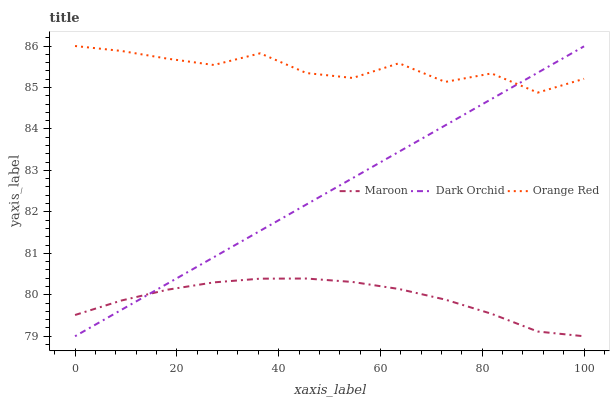Does Maroon have the minimum area under the curve?
Answer yes or no. Yes. Does Orange Red have the maximum area under the curve?
Answer yes or no. Yes. Does Orange Red have the minimum area under the curve?
Answer yes or no. No. Does Maroon have the maximum area under the curve?
Answer yes or no. No. Is Dark Orchid the smoothest?
Answer yes or no. Yes. Is Orange Red the roughest?
Answer yes or no. Yes. Is Maroon the smoothest?
Answer yes or no. No. Is Maroon the roughest?
Answer yes or no. No. Does Dark Orchid have the lowest value?
Answer yes or no. Yes. Does Orange Red have the lowest value?
Answer yes or no. No. Does Orange Red have the highest value?
Answer yes or no. Yes. Does Maroon have the highest value?
Answer yes or no. No. Is Maroon less than Orange Red?
Answer yes or no. Yes. Is Orange Red greater than Maroon?
Answer yes or no. Yes. Does Maroon intersect Dark Orchid?
Answer yes or no. Yes. Is Maroon less than Dark Orchid?
Answer yes or no. No. Is Maroon greater than Dark Orchid?
Answer yes or no. No. Does Maroon intersect Orange Red?
Answer yes or no. No. 